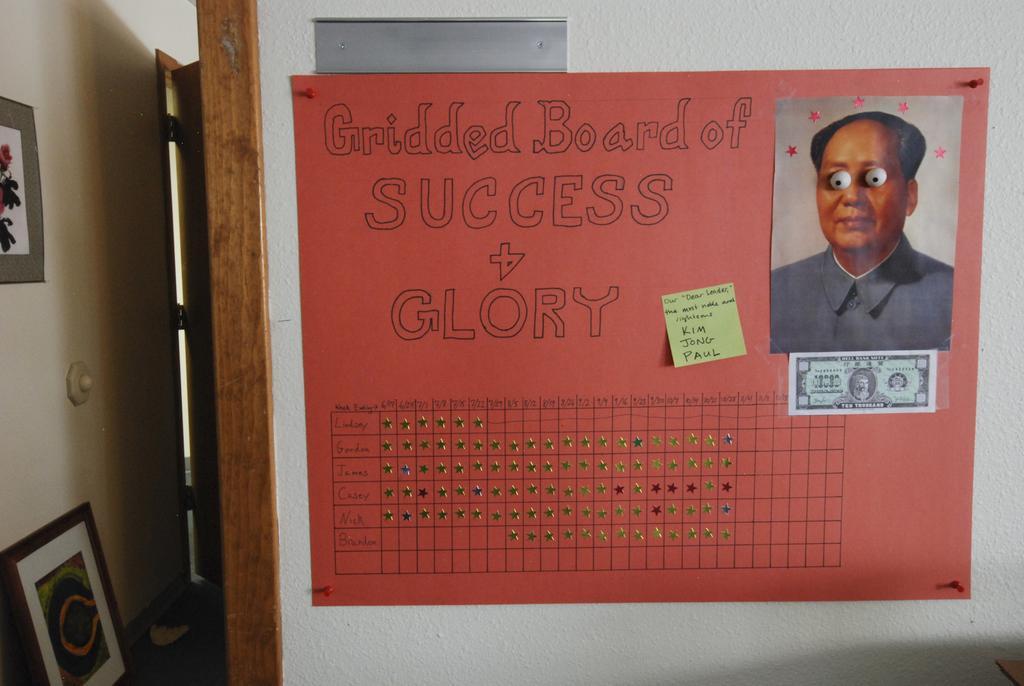How would you summarize this image in a sentence or two? In this image there is a wall on the right side of this image and there is one poster is attached on the wall. There is a picture of a person is attached on the wall as we can see on the right side of this image. There is one frame is attached on the wall on the left side of this image and there is one another photo frame is in the bottom left corner of this image. 